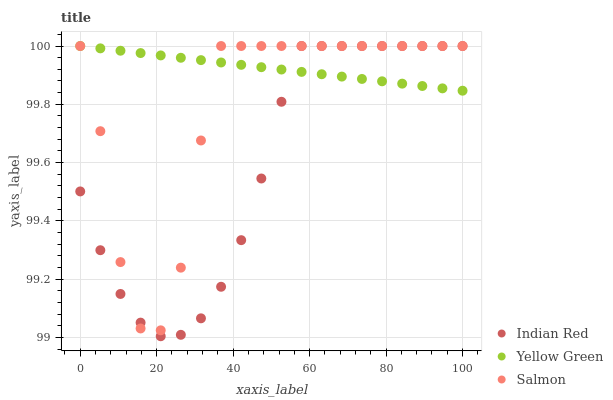Does Indian Red have the minimum area under the curve?
Answer yes or no. Yes. Does Yellow Green have the maximum area under the curve?
Answer yes or no. Yes. Does Yellow Green have the minimum area under the curve?
Answer yes or no. No. Does Indian Red have the maximum area under the curve?
Answer yes or no. No. Is Yellow Green the smoothest?
Answer yes or no. Yes. Is Salmon the roughest?
Answer yes or no. Yes. Is Indian Red the smoothest?
Answer yes or no. No. Is Indian Red the roughest?
Answer yes or no. No. Does Indian Red have the lowest value?
Answer yes or no. Yes. Does Yellow Green have the lowest value?
Answer yes or no. No. Does Indian Red have the highest value?
Answer yes or no. Yes. Does Indian Red intersect Yellow Green?
Answer yes or no. Yes. Is Indian Red less than Yellow Green?
Answer yes or no. No. Is Indian Red greater than Yellow Green?
Answer yes or no. No. 